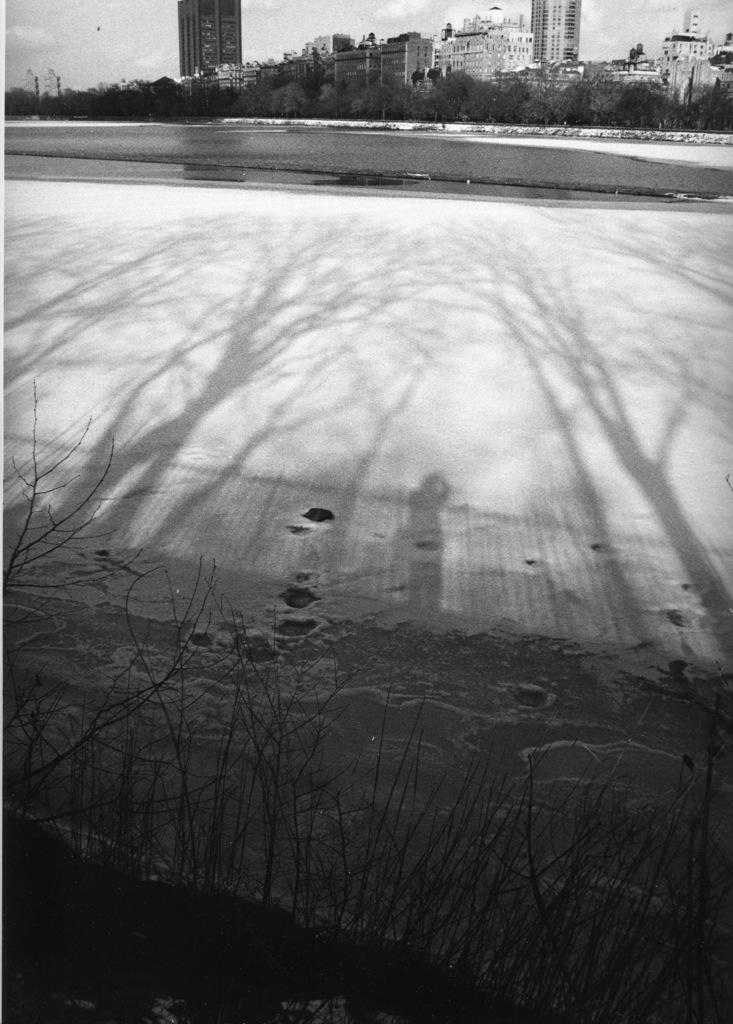What can be seen on the ground in the image? There is a path in the image. What is visible in the background of the image? There are buildings visible in the distance. What part of the natural environment is visible in the image? The sky is visible in the image. What is the condition of the sky in the image? Clouds are present in the sky. Can you see the farmer carrying a sack on the path in the image? There is no farmer or sack present in the image. 